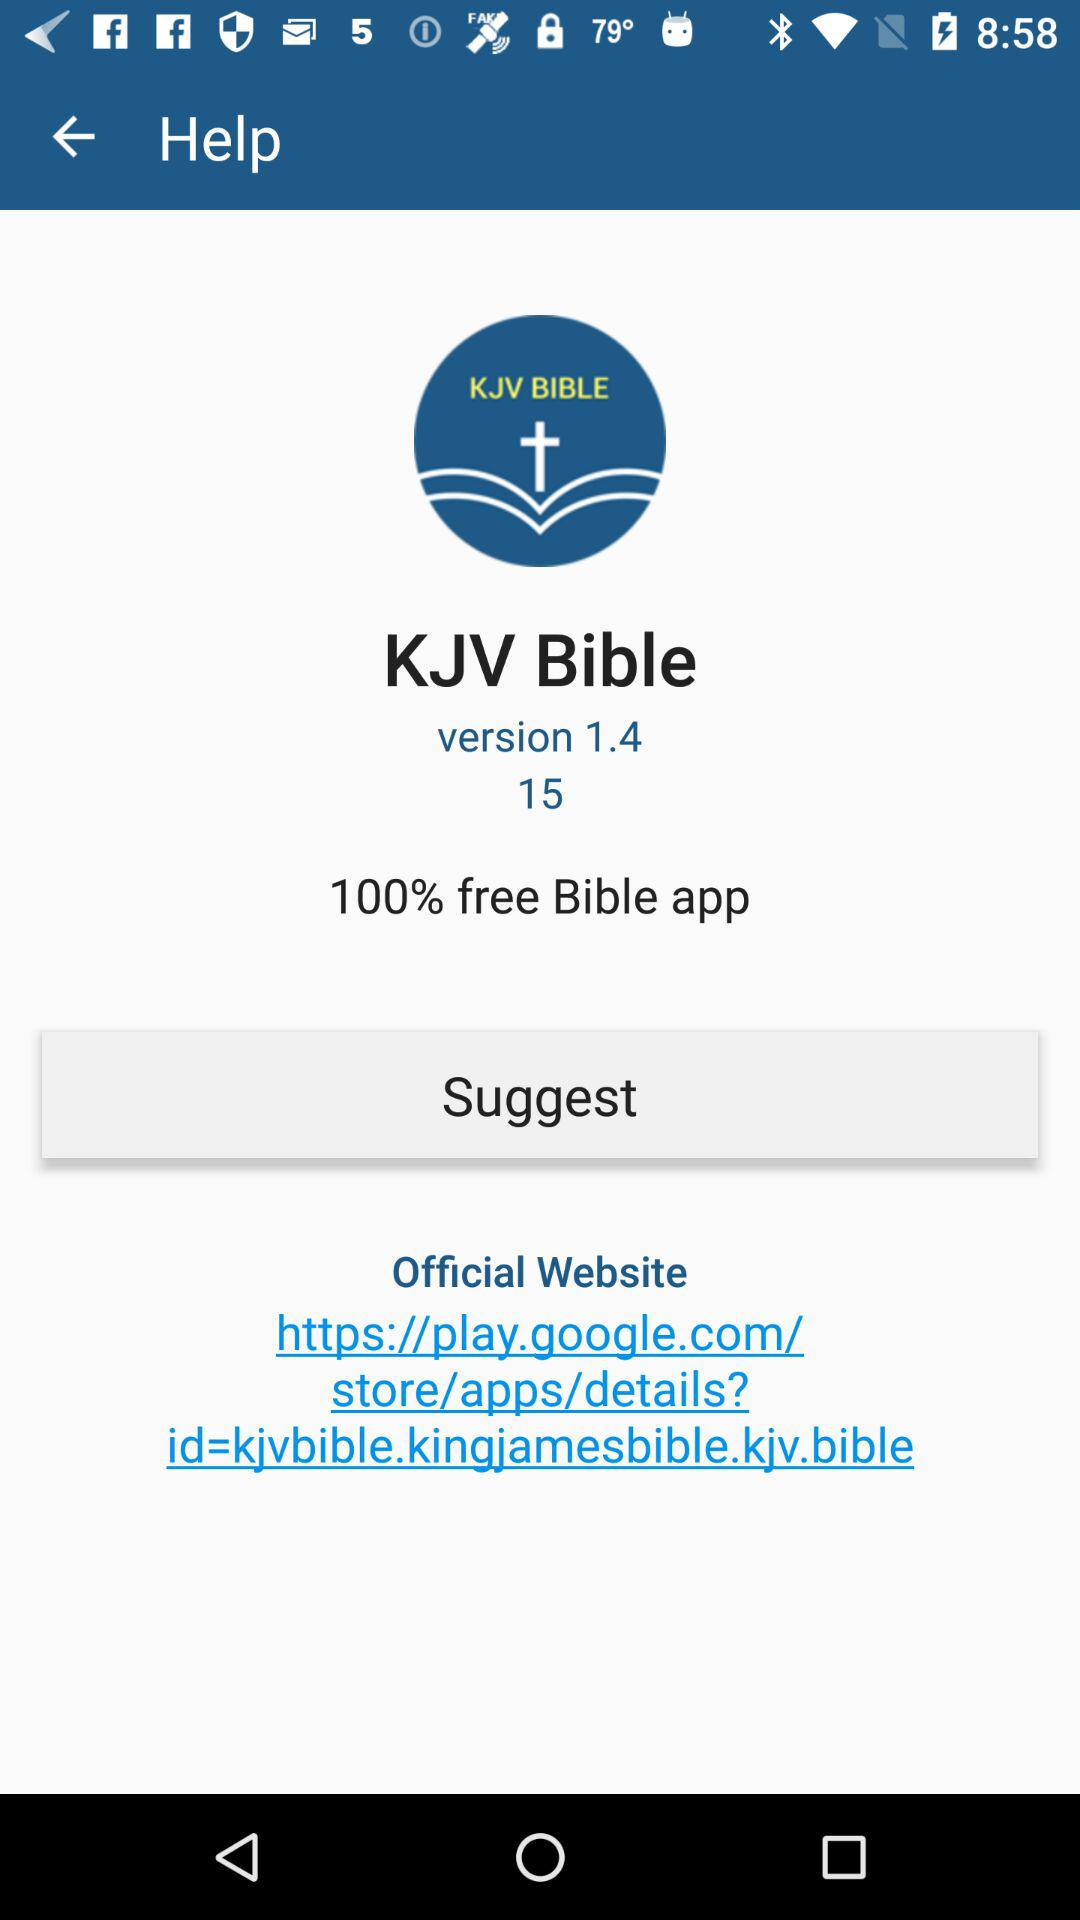Which version is this? The version is 1.4. 